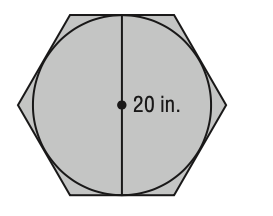Question: What is the area of the figure? Round to the nearest tenth.
Choices:
A. 346.4
B. 372.1
C. 383.2
D. 564.7
Answer with the letter. Answer: A 